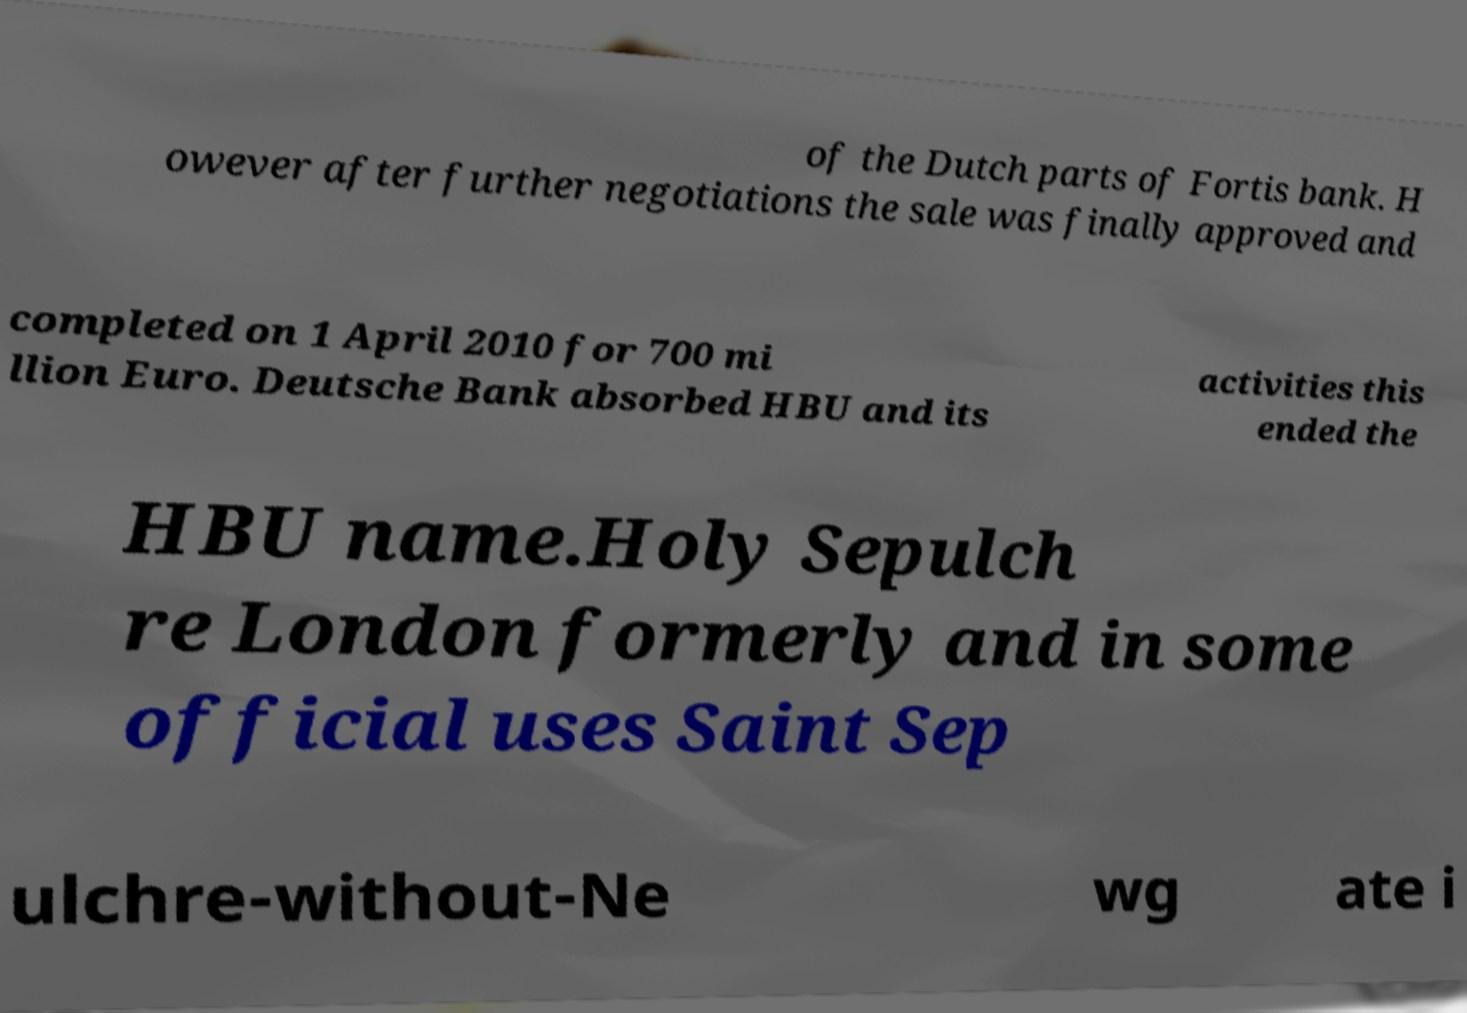What messages or text are displayed in this image? I need them in a readable, typed format. of the Dutch parts of Fortis bank. H owever after further negotiations the sale was finally approved and completed on 1 April 2010 for 700 mi llion Euro. Deutsche Bank absorbed HBU and its activities this ended the HBU name.Holy Sepulch re London formerly and in some official uses Saint Sep ulchre-without-Ne wg ate i 